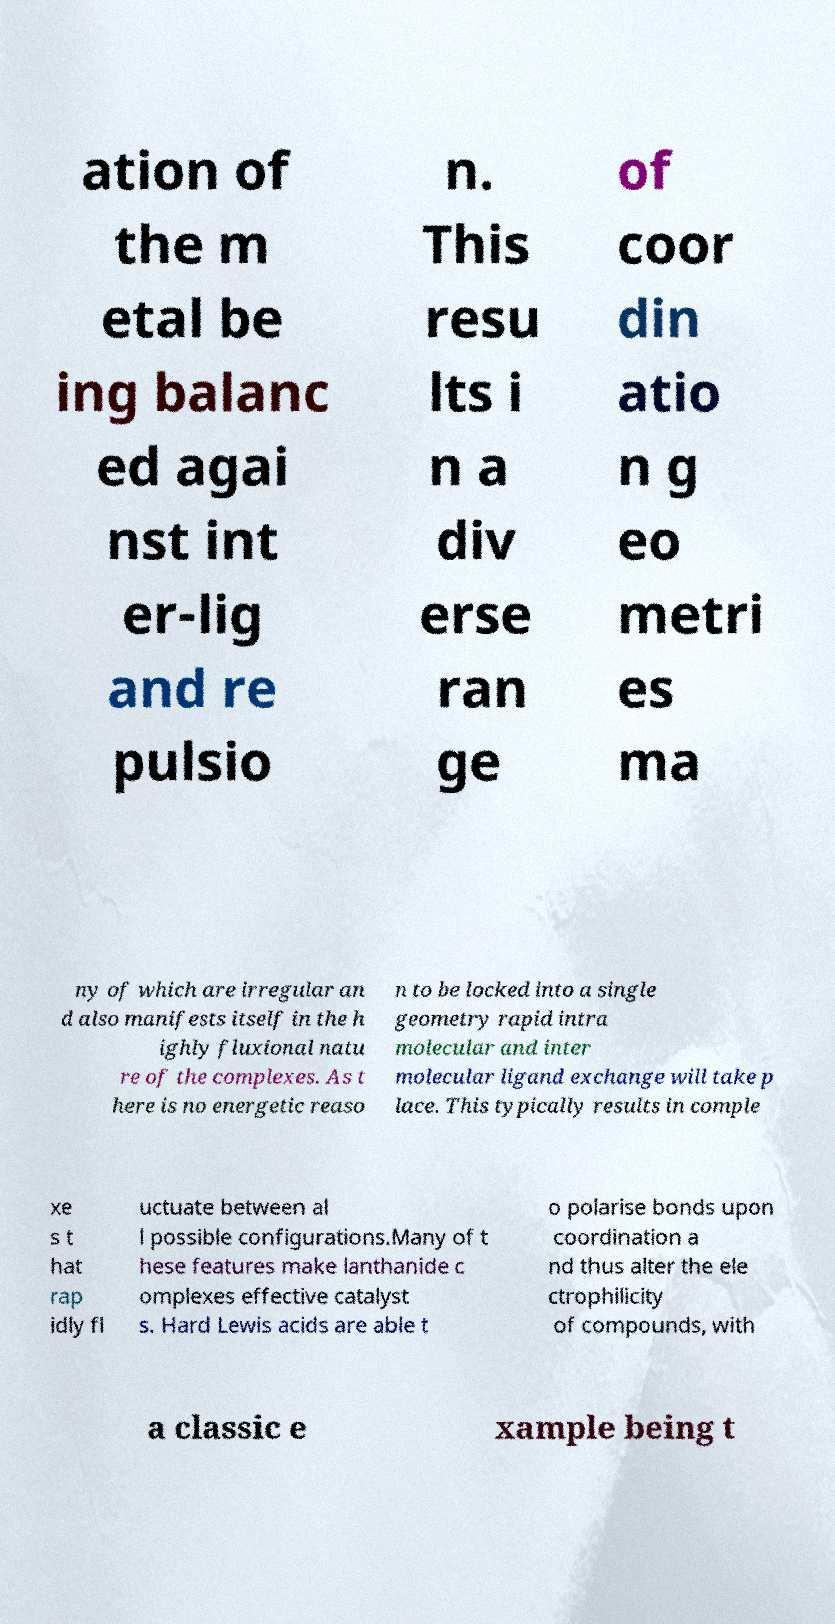Can you accurately transcribe the text from the provided image for me? ation of the m etal be ing balanc ed agai nst int er-lig and re pulsio n. This resu lts i n a div erse ran ge of coor din atio n g eo metri es ma ny of which are irregular an d also manifests itself in the h ighly fluxional natu re of the complexes. As t here is no energetic reaso n to be locked into a single geometry rapid intra molecular and inter molecular ligand exchange will take p lace. This typically results in comple xe s t hat rap idly fl uctuate between al l possible configurations.Many of t hese features make lanthanide c omplexes effective catalyst s. Hard Lewis acids are able t o polarise bonds upon coordination a nd thus alter the ele ctrophilicity of compounds, with a classic e xample being t 